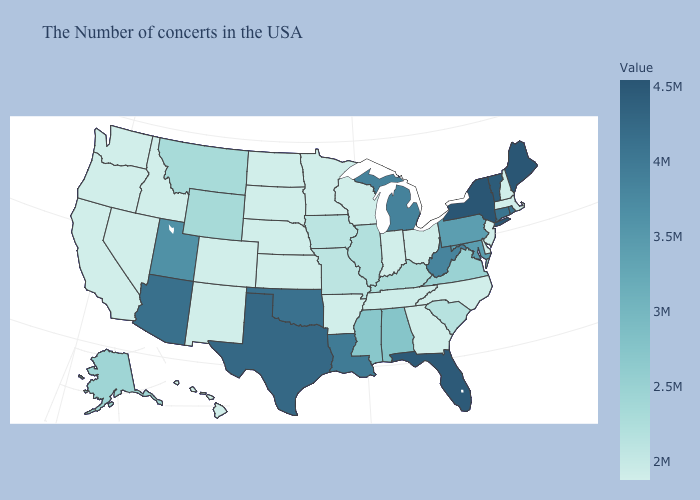Does Michigan have the highest value in the MidWest?
Short answer required. Yes. Does Iowa have the lowest value in the MidWest?
Quick response, please. No. Among the states that border Mississippi , does Louisiana have the lowest value?
Be succinct. No. Does Wisconsin have a lower value than Wyoming?
Quick response, please. Yes. Does Arizona have the highest value in the West?
Give a very brief answer. Yes. 